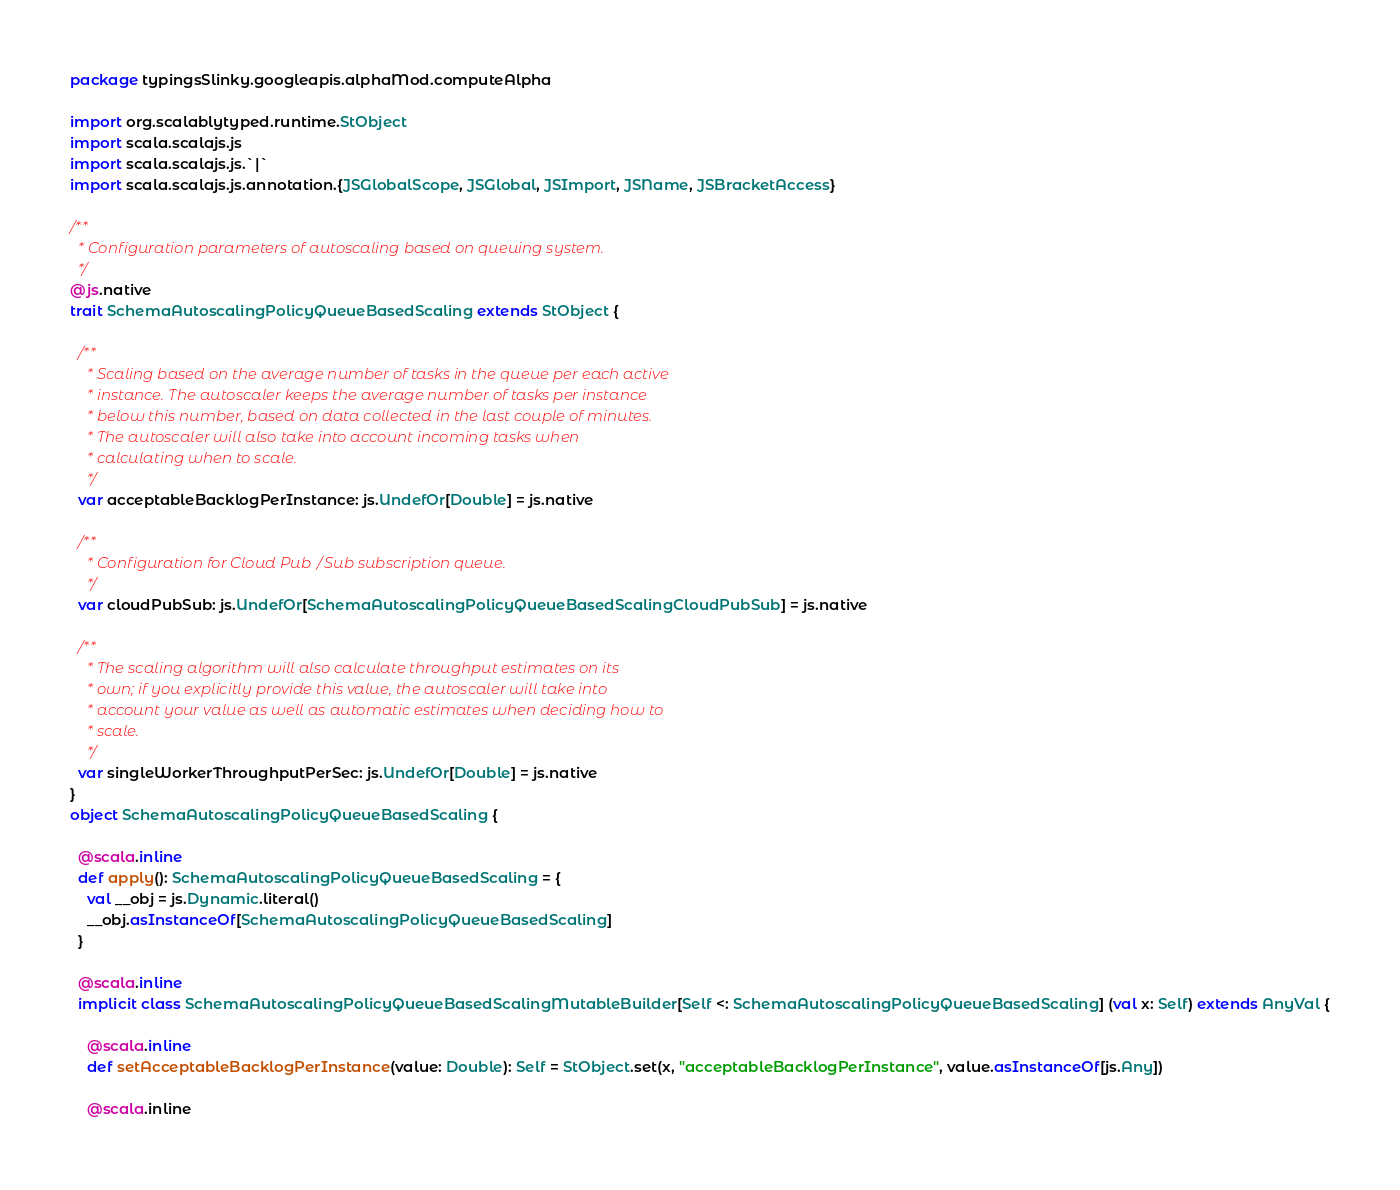<code> <loc_0><loc_0><loc_500><loc_500><_Scala_>package typingsSlinky.googleapis.alphaMod.computeAlpha

import org.scalablytyped.runtime.StObject
import scala.scalajs.js
import scala.scalajs.js.`|`
import scala.scalajs.js.annotation.{JSGlobalScope, JSGlobal, JSImport, JSName, JSBracketAccess}

/**
  * Configuration parameters of autoscaling based on queuing system.
  */
@js.native
trait SchemaAutoscalingPolicyQueueBasedScaling extends StObject {
  
  /**
    * Scaling based on the average number of tasks in the queue per each active
    * instance. The autoscaler keeps the average number of tasks per instance
    * below this number, based on data collected in the last couple of minutes.
    * The autoscaler will also take into account incoming tasks when
    * calculating when to scale.
    */
  var acceptableBacklogPerInstance: js.UndefOr[Double] = js.native
  
  /**
    * Configuration for Cloud Pub/Sub subscription queue.
    */
  var cloudPubSub: js.UndefOr[SchemaAutoscalingPolicyQueueBasedScalingCloudPubSub] = js.native
  
  /**
    * The scaling algorithm will also calculate throughput estimates on its
    * own; if you explicitly provide this value, the autoscaler will take into
    * account your value as well as automatic estimates when deciding how to
    * scale.
    */
  var singleWorkerThroughputPerSec: js.UndefOr[Double] = js.native
}
object SchemaAutoscalingPolicyQueueBasedScaling {
  
  @scala.inline
  def apply(): SchemaAutoscalingPolicyQueueBasedScaling = {
    val __obj = js.Dynamic.literal()
    __obj.asInstanceOf[SchemaAutoscalingPolicyQueueBasedScaling]
  }
  
  @scala.inline
  implicit class SchemaAutoscalingPolicyQueueBasedScalingMutableBuilder[Self <: SchemaAutoscalingPolicyQueueBasedScaling] (val x: Self) extends AnyVal {
    
    @scala.inline
    def setAcceptableBacklogPerInstance(value: Double): Self = StObject.set(x, "acceptableBacklogPerInstance", value.asInstanceOf[js.Any])
    
    @scala.inline</code> 